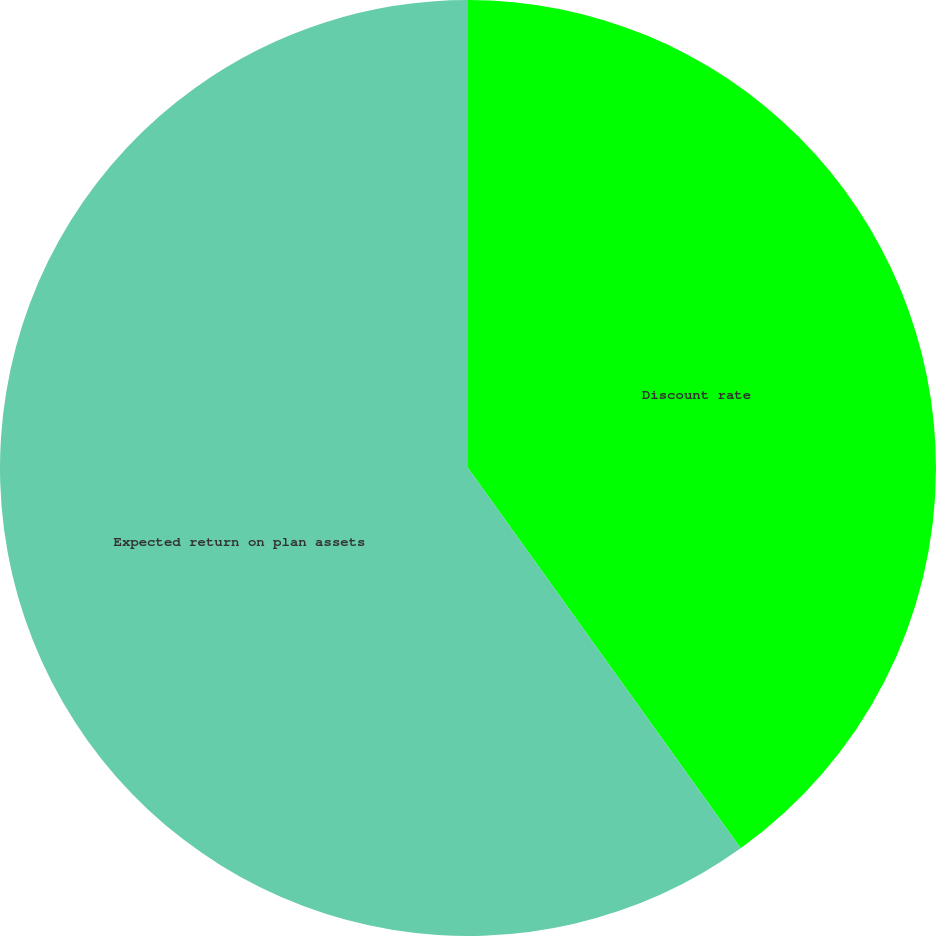Convert chart to OTSL. <chart><loc_0><loc_0><loc_500><loc_500><pie_chart><fcel>Discount rate<fcel>Expected return on plan assets<nl><fcel>40.1%<fcel>59.9%<nl></chart> 